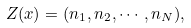Convert formula to latex. <formula><loc_0><loc_0><loc_500><loc_500>Z ( x ) = ( n _ { 1 } , n _ { 2 } , \cdots , n _ { N } ) ,</formula> 